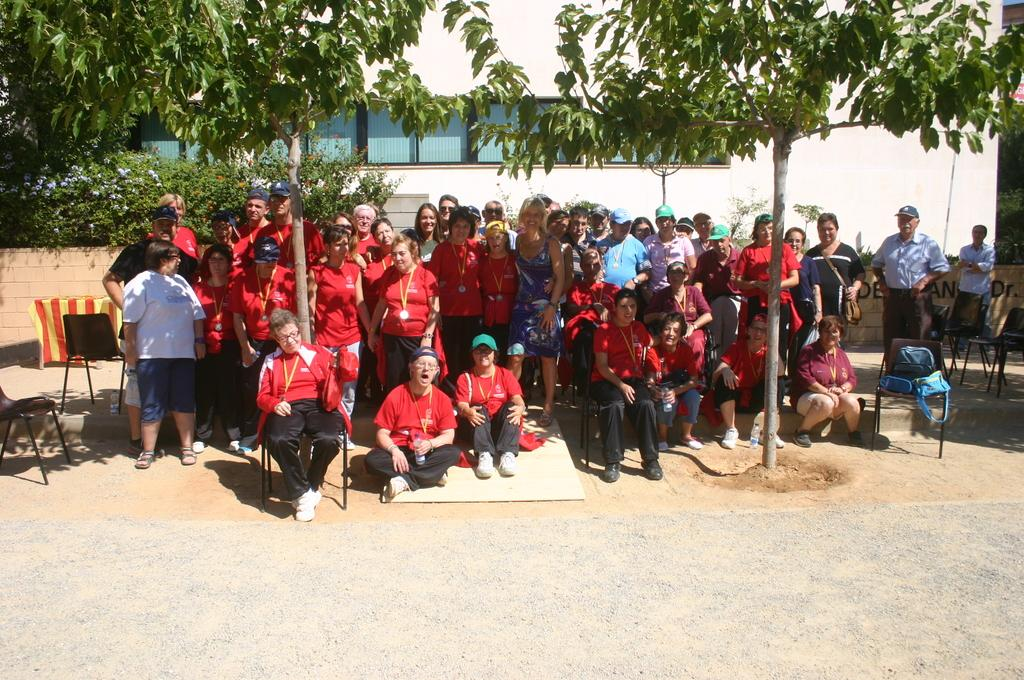How many people are in the image? There is a group of people in the image, but the exact number cannot be determined from the provided facts. What are the people in the image doing? The people are posing for a picture. What objects can be seen in the image besides the people? There are bags, chairs, trees, and a building in the image. What type of mountain can be seen in the background of the image? There is no mountain visible in the image; it features a group of people posing for a picture, bags, chairs, trees, and a building. What color is the underwear worn by the people in the image? The provided facts do not mention any underwear, so it cannot be determined from the image. 